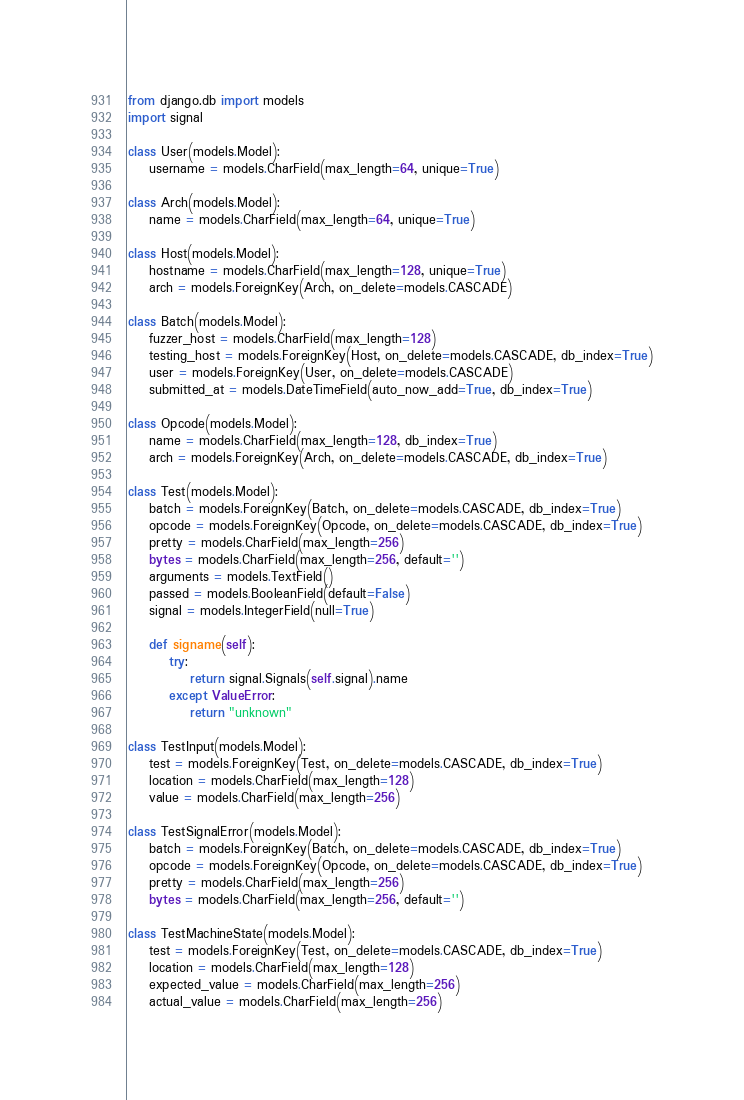Convert code to text. <code><loc_0><loc_0><loc_500><loc_500><_Python_>from django.db import models
import signal

class User(models.Model):
    username = models.CharField(max_length=64, unique=True)

class Arch(models.Model):
    name = models.CharField(max_length=64, unique=True)

class Host(models.Model):
    hostname = models.CharField(max_length=128, unique=True)
    arch = models.ForeignKey(Arch, on_delete=models.CASCADE)

class Batch(models.Model):
    fuzzer_host = models.CharField(max_length=128)
    testing_host = models.ForeignKey(Host, on_delete=models.CASCADE, db_index=True)
    user = models.ForeignKey(User, on_delete=models.CASCADE)
    submitted_at = models.DateTimeField(auto_now_add=True, db_index=True)

class Opcode(models.Model):
    name = models.CharField(max_length=128, db_index=True)
    arch = models.ForeignKey(Arch, on_delete=models.CASCADE, db_index=True)

class Test(models.Model):
    batch = models.ForeignKey(Batch, on_delete=models.CASCADE, db_index=True)
    opcode = models.ForeignKey(Opcode, on_delete=models.CASCADE, db_index=True)
    pretty = models.CharField(max_length=256)
    bytes = models.CharField(max_length=256, default='')
    arguments = models.TextField()
    passed = models.BooleanField(default=False)
    signal = models.IntegerField(null=True)

    def signame(self):
        try:
            return signal.Signals(self.signal).name
        except ValueError:
            return "unknown"

class TestInput(models.Model):
    test = models.ForeignKey(Test, on_delete=models.CASCADE, db_index=True)
    location = models.CharField(max_length=128)
    value = models.CharField(max_length=256)

class TestSignalError(models.Model):
    batch = models.ForeignKey(Batch, on_delete=models.CASCADE, db_index=True)
    opcode = models.ForeignKey(Opcode, on_delete=models.CASCADE, db_index=True)
    pretty = models.CharField(max_length=256)
    bytes = models.CharField(max_length=256, default='')

class TestMachineState(models.Model):
    test = models.ForeignKey(Test, on_delete=models.CASCADE, db_index=True)
    location = models.CharField(max_length=128)
    expected_value = models.CharField(max_length=256)
    actual_value = models.CharField(max_length=256)
</code> 